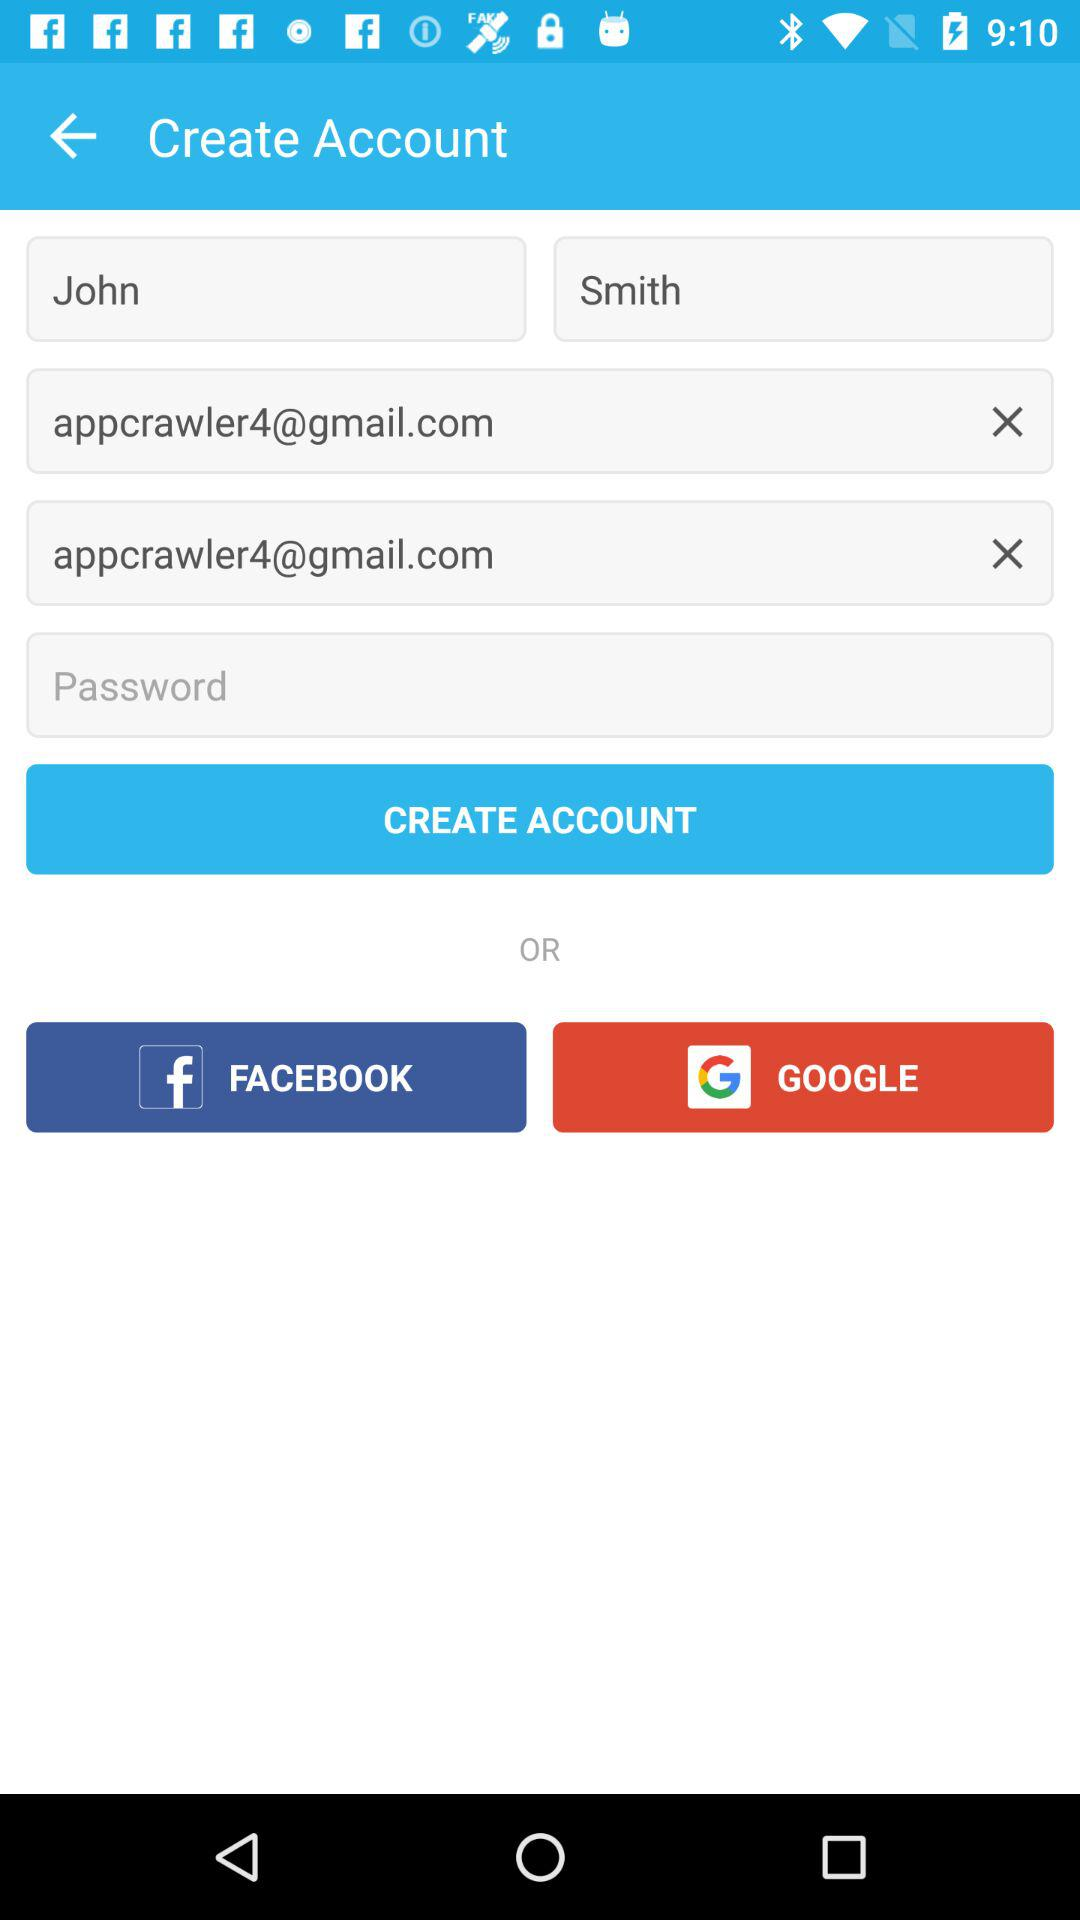What is the first name? The first name is John. 